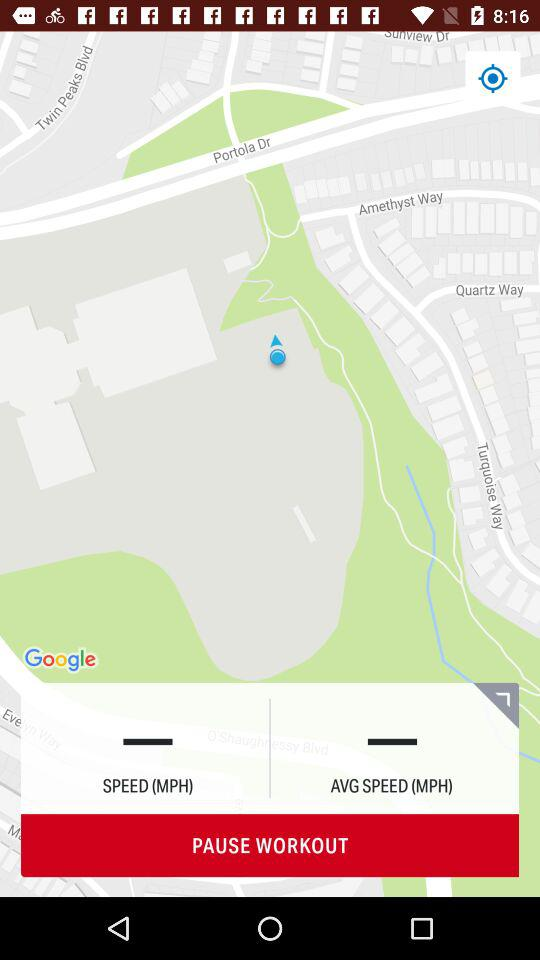What is the application name? The name of the application is "mapmyride". 